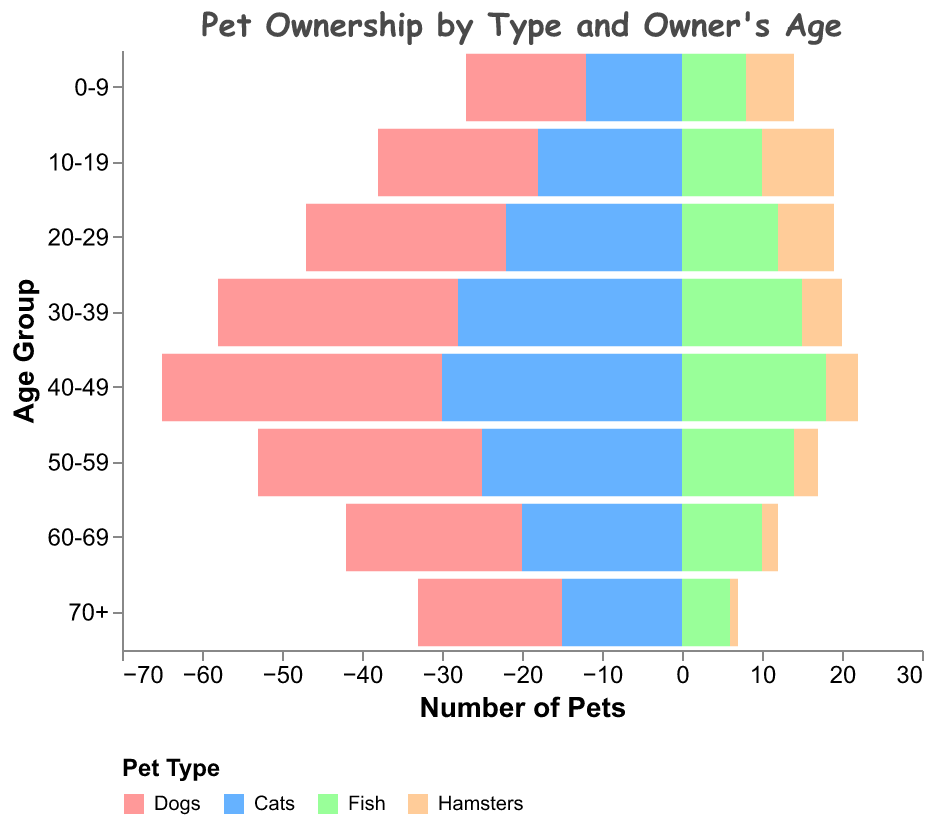What's the title of the figure? The title is prominently displayed at the top of the figure. It helps understand the overall topic of the figure.
Answer: Pet Ownership by Type and Owner's Age Which pet type has the highest ownership in the 30-39 age group? Look at the 30-39 age group and compare the bars for Dogs, Cats, Fish, and Hamsters. The tallest bar indicates the highest ownership for Dogs.
Answer: Dogs How many pets in total are owned by the 20-29 age group? For the 20-29 age group, sum the values for Dogs, Cats, Fish, and Hamsters (25 + 22 + 12 + 7).
Answer: 66 Does the number of Hamster owners increase or decrease with higher age groups? Starting from the youngest to the oldest age groups, observe the values for Hamsters. They consistently decrease.
Answer: Decrease Compare the number of Cat owners between the 40-49 age group and the 50-59 age group. Check the values for Cat owners in the 40-49 age group (30) and the 50-59 age group (25) and determine which is higher.
Answer: 40-49 age group Which age group has the least number of Fish owners? Compare the values for Fish ownership across all age groups and find the smallest value (6 in the 70+ age group).
Answer: 70+ What's the most popular pet across all age groups combined? Sum the values for each pet type across all age groups and compare the totals: Dogs (15+20+25+30+35+28+22+18), Cats (12+18+22+28+30+25+20+15), Fish (8+10+12+15+18+14+10+6), Hamsters (6+9+7+5+4+3+2+1). Dogs have the highest total.
Answer: Dogs Which age group sees the sharpest decline from one pet type to another? Look for the age group where the difference between the highest and lowest pet ownership values is greatest. In the 40-49 age group, the difference between Dogs (35) and Hamsters (4) is the highest.
Answer: 40-49 age group 